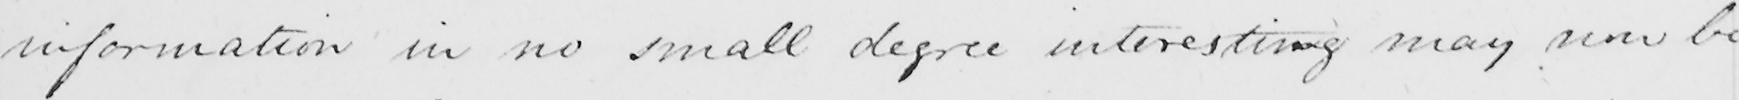What is written in this line of handwriting? information in no small degree interesting may now be 